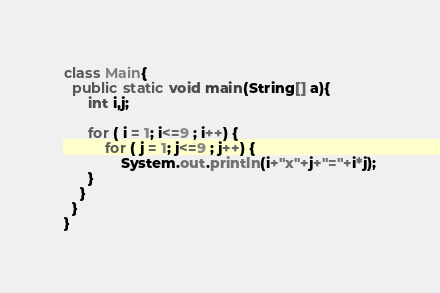<code> <loc_0><loc_0><loc_500><loc_500><_Java_>class Main{
  public static void main(String[] a){
	  int i,j;

	  for ( i = 1; i<=9 ; i++) {
		  for ( j = 1; j<=9 ; j++) {
			  System.out.println(i+"x"+j+"="+i*j);
      }
    }
  }
}</code> 